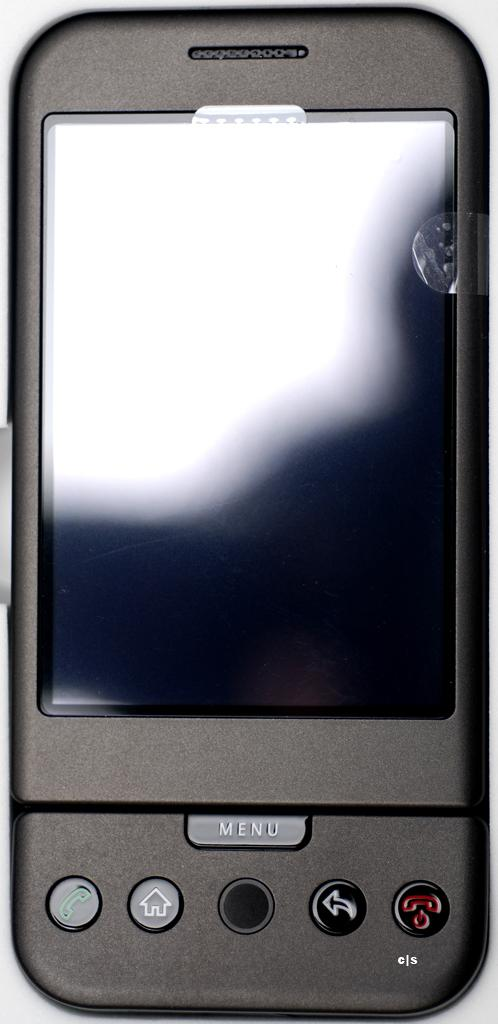Provide a one-sentence caption for the provided image. black cell phone that has a protector on the screen and a menu button. 